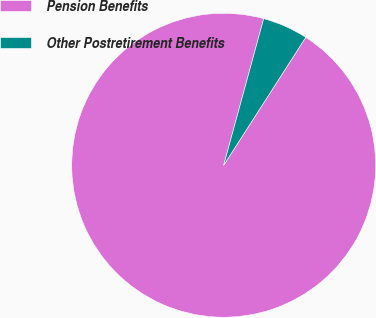<chart> <loc_0><loc_0><loc_500><loc_500><pie_chart><fcel>Pension Benefits<fcel>Other Postretirement Benefits<nl><fcel>95.16%<fcel>4.84%<nl></chart> 